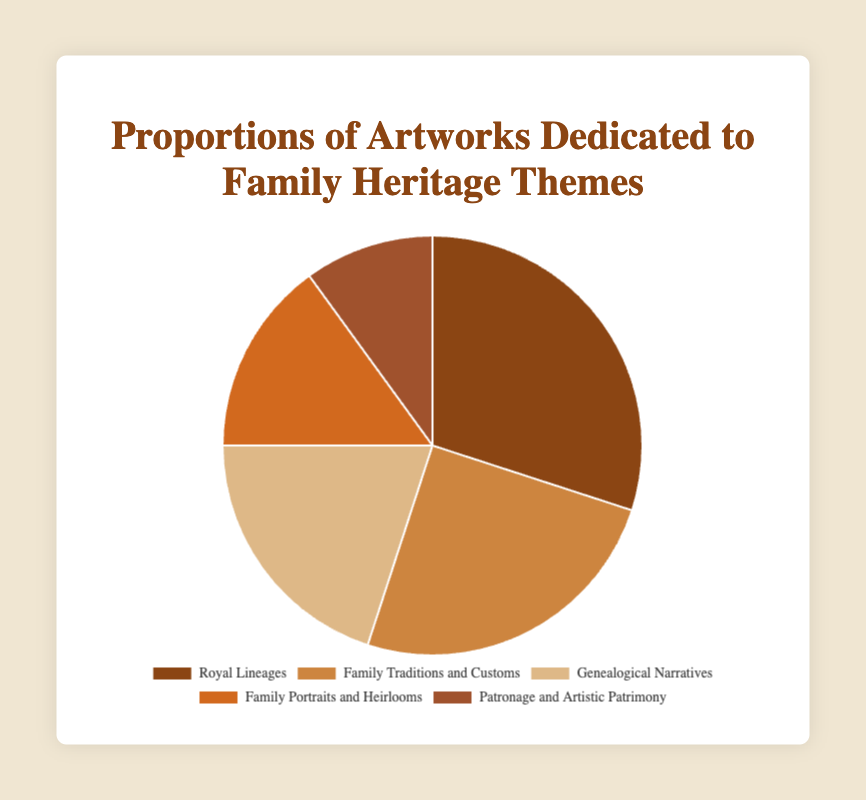Which theme has the highest proportion of artworks? The figure shows five themes with distinct proportions. The theme with the highest proportion is located at the largest segment of the pie chart.
Answer: Royal Lineages How much greater is the proportion of artworks dedicated to Family Traditions and Customs compared to Patronage and Artistic Patrimony? First, find the proportions for both themes in the figure: Family Traditions and Customs at 25% and Patronage and Artistic Patrimony at 10%. Subtract the smaller value from the larger value: 25% - 10% = 15%.
Answer: 15% What is the combined proportion of artworks dedicated to Royal Lineages and Genealogical Narratives? The proportions are 30% for Royal Lineages and 20% for Genealogical Narratives. Adding these proportions together gives: 30% + 20% = 50%.
Answer: 50% Which theme has a smaller proportion: Family Portraits and Heirlooms or Genealogical Narratives? By comparing the two segments in the pie chart, Family Portraits and Heirlooms has 15% while Genealogical Narratives has 20%.
Answer: Family Portraits and Heirlooms What is the average proportion of artworks dedicated to all the themes? To find the average, sum the proportions: 30% + 25% + 20% + 15% + 10% = 100%. Then divide by the number of themes (5): 100% / 5 = 20%.
Answer: 20% What proportion of artworks are not dedicated to Royal Lineages? The total proportion is always 100%. Subtract the proportion for Royal Lineages from the total: 100% - 30% = 70%.
Answer: 70% What are the three themes with the smallest proportions? Identify the proportions in descending order until the three smallest values are found: Family Portraits and Heirlooms (15%), Genealogical Narratives (20%), and Patronage and Artistic Patrimony (10%).
Answer: Family Portraits and Heirlooms, Genealogical Narratives, and Patronage and Artistic Patrimony If you combined the proportions of artworks dedicated to Family Portraits and Heirlooms and Patronage and Artistic Patrimony, what would be their new segment's size compared to Family Traditions and Customs? Sum the proportions for Family Portraits and Heirlooms (15%) and Patronage and Artistic Patrimony (10%) to get the combined segment, 15% + 10% = 25%. This is equal to the proportion for Family Traditions and Customs, so their sizes are the same.
Answer: Equal 